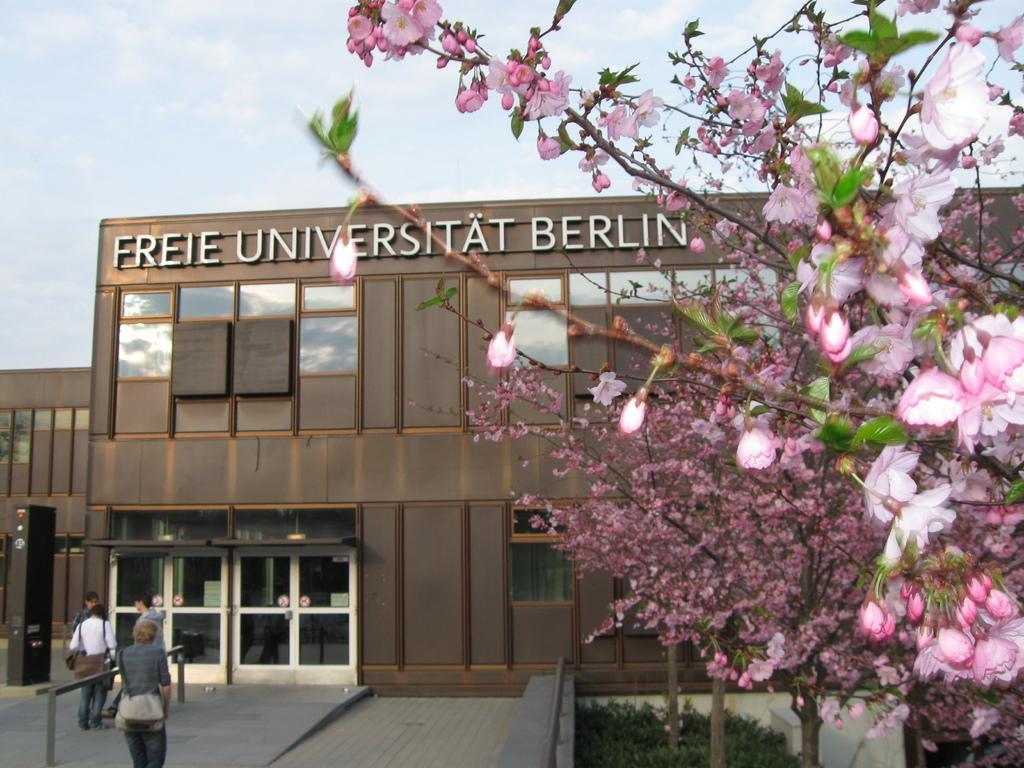Please provide a concise description of this image. In this image we can see group of people wearing bags are standing on the ground. On the left side of the image we can see a metal pole. On the right side of the image we can see group of flowers on trees, we can also see some plants. In the center of the image we can see a building with windows, door and a board with some text. At the top of the image we can see the sky. 